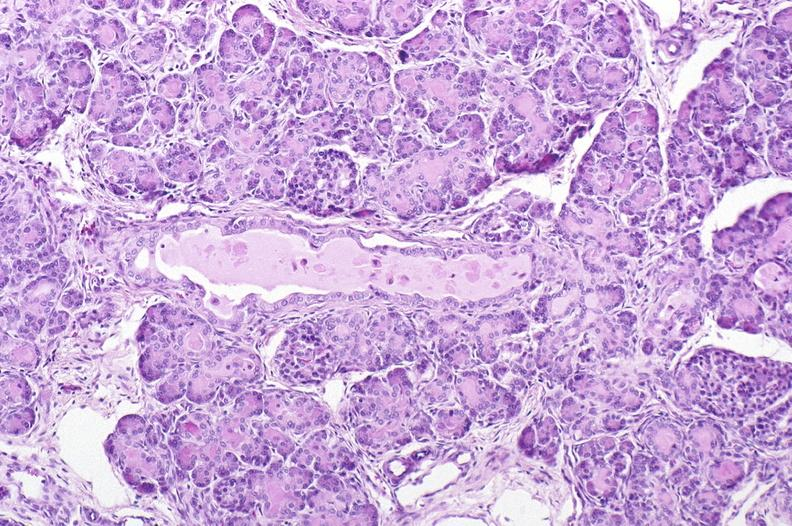where is this?
Answer the question using a single word or phrase. Pancreas 